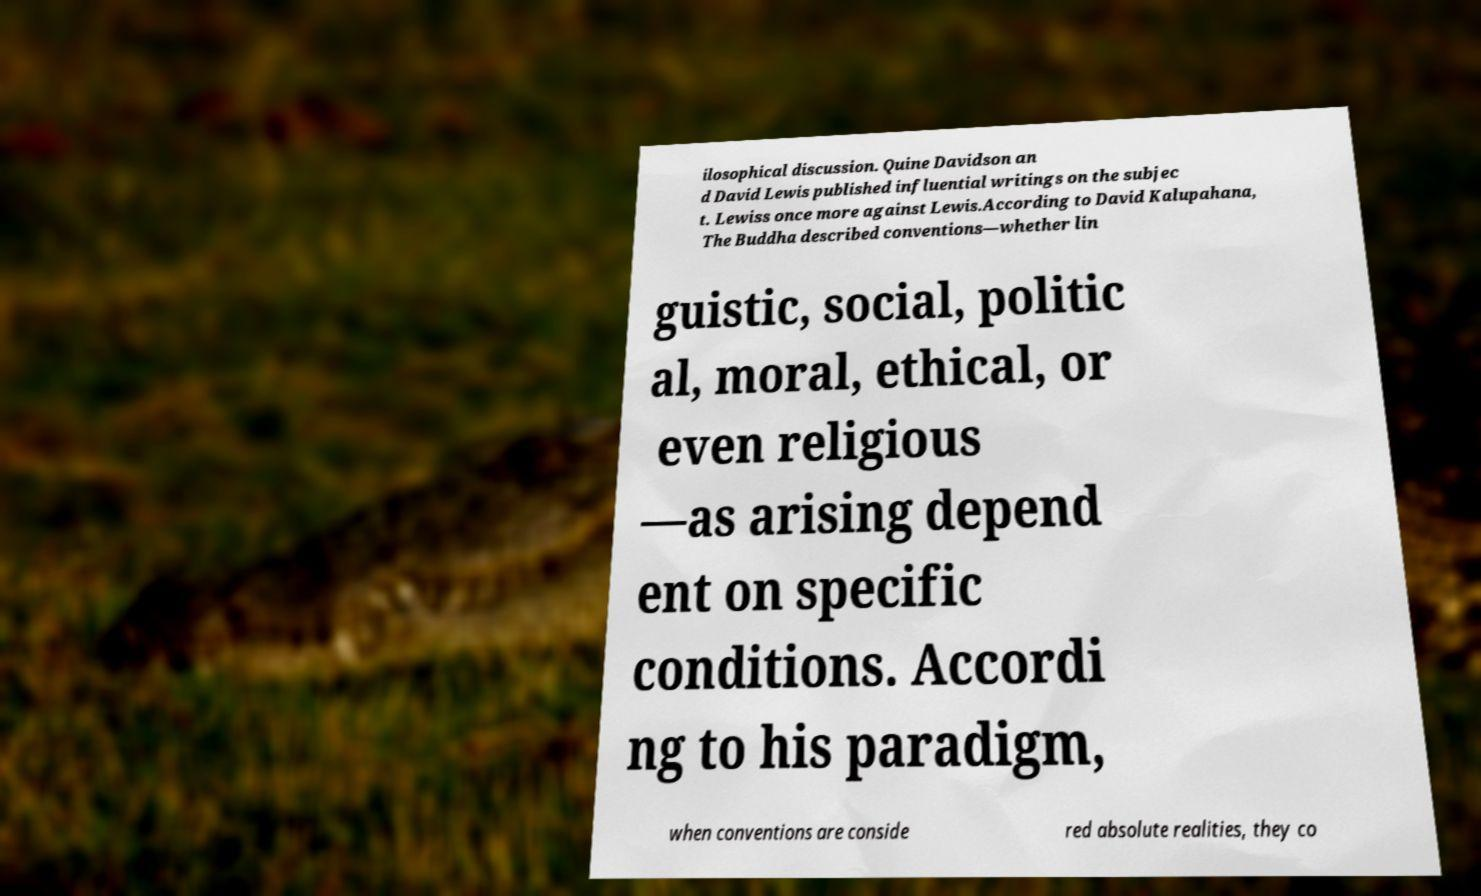There's text embedded in this image that I need extracted. Can you transcribe it verbatim? ilosophical discussion. Quine Davidson an d David Lewis published influential writings on the subjec t. Lewiss once more against Lewis.According to David Kalupahana, The Buddha described conventions—whether lin guistic, social, politic al, moral, ethical, or even religious —as arising depend ent on specific conditions. Accordi ng to his paradigm, when conventions are conside red absolute realities, they co 